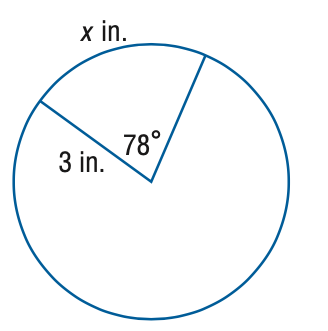Answer the mathemtical geometry problem and directly provide the correct option letter.
Question: Find the value of x.
Choices: A: 1.02 B: 2.04 C: 4.08 D: 8.17 C 